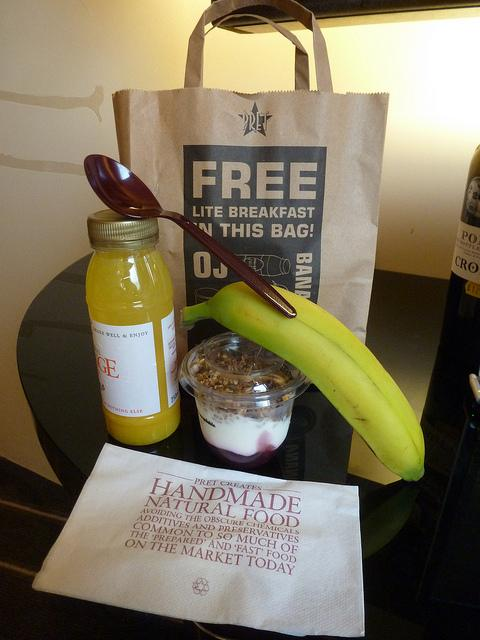What liquid have they been given for breakfast? Please explain your reasoning. orange juice. You can tell by the color and other foods around it as to what is in the bottle. 